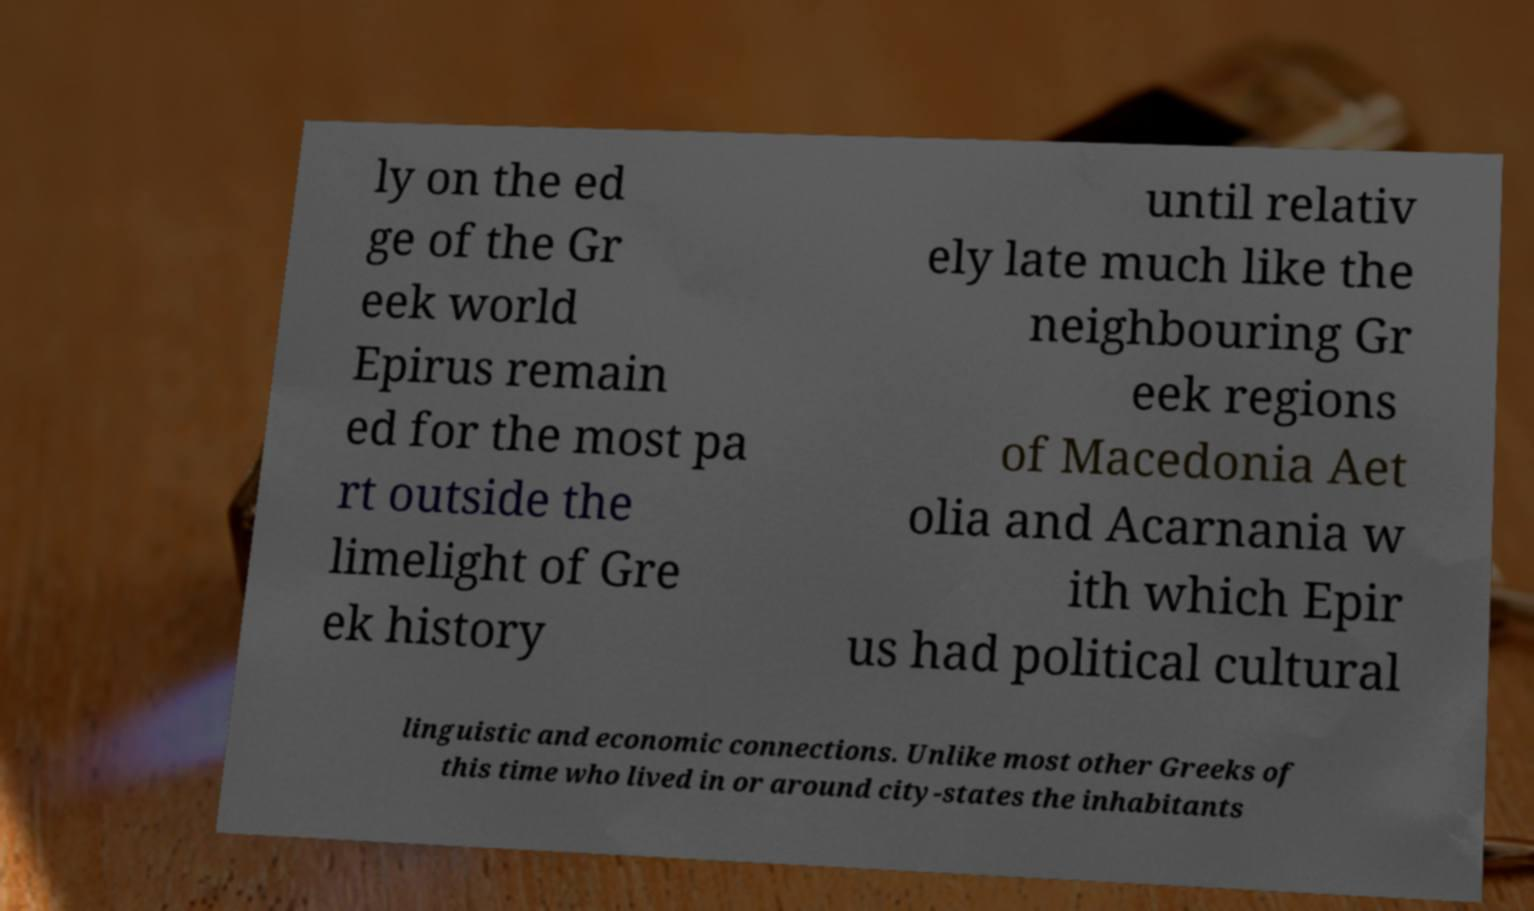There's text embedded in this image that I need extracted. Can you transcribe it verbatim? ly on the ed ge of the Gr eek world Epirus remain ed for the most pa rt outside the limelight of Gre ek history until relativ ely late much like the neighbouring Gr eek regions of Macedonia Aet olia and Acarnania w ith which Epir us had political cultural linguistic and economic connections. Unlike most other Greeks of this time who lived in or around city-states the inhabitants 